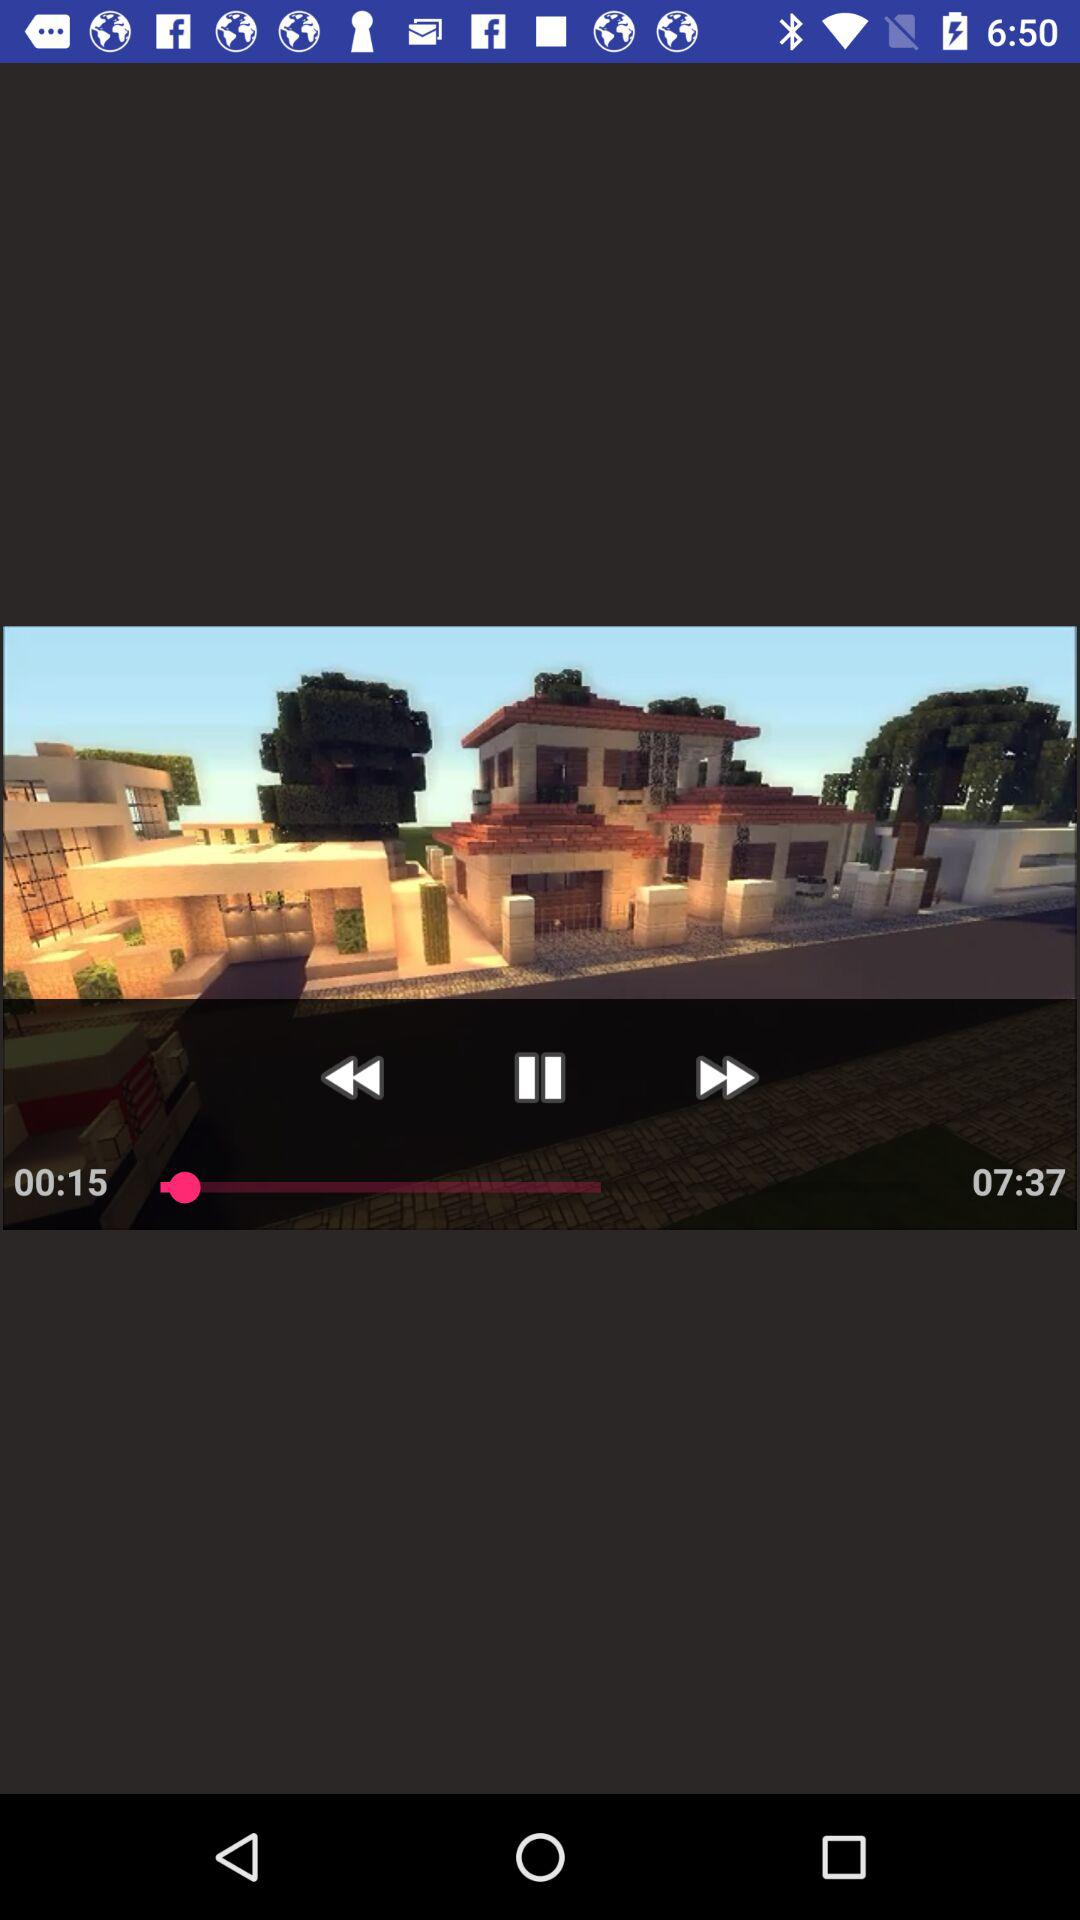How long is the video?
Answer the question using a single word or phrase. 07:37 